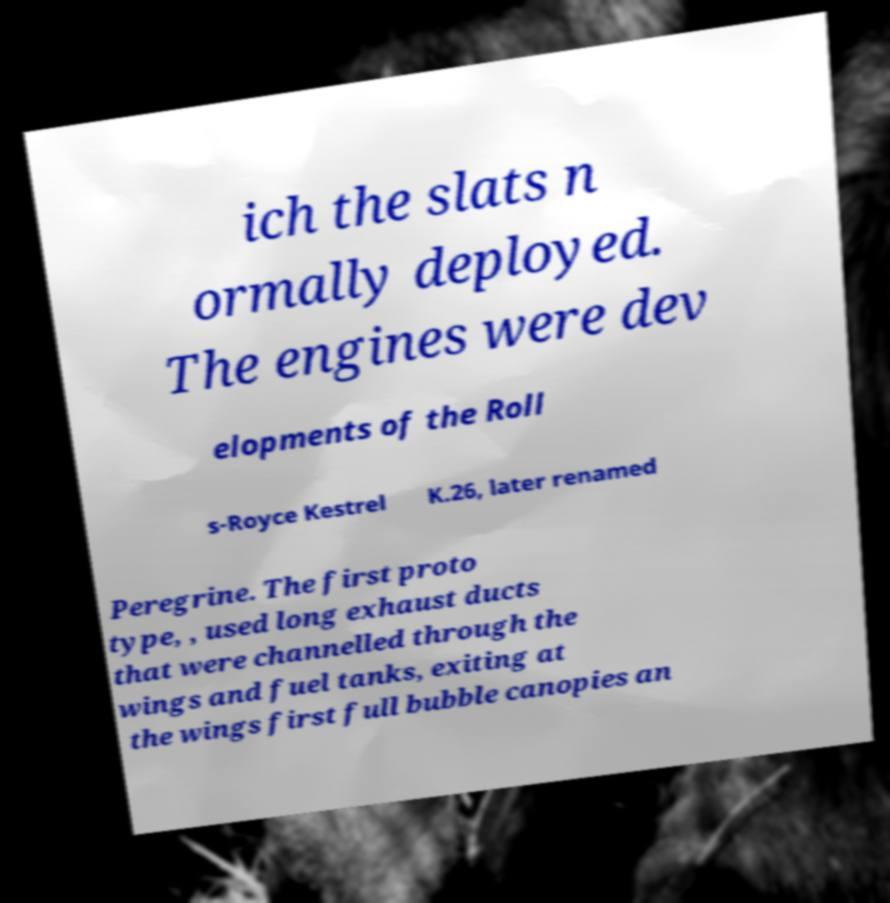There's text embedded in this image that I need extracted. Can you transcribe it verbatim? ich the slats n ormally deployed. The engines were dev elopments of the Roll s-Royce Kestrel K.26, later renamed Peregrine. The first proto type, , used long exhaust ducts that were channelled through the wings and fuel tanks, exiting at the wings first full bubble canopies an 